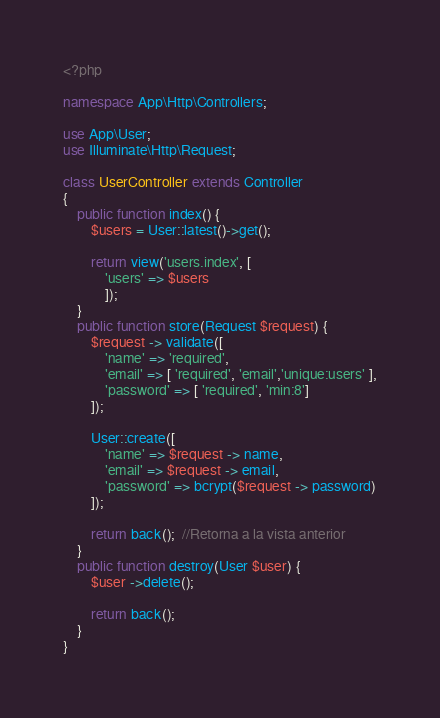Convert code to text. <code><loc_0><loc_0><loc_500><loc_500><_PHP_><?php

namespace App\Http\Controllers;

use App\User;
use Illuminate\Http\Request;

class UserController extends Controller
{
    public function index() {
        $users = User::latest()->get();

        return view('users.index', [
            'users' => $users
            ]);
    }
    public function store(Request $request) {
        $request -> validate([
            'name' => 'required',
            'email' => [ 'required', 'email','unique:users' ],
            'password' => [ 'required', 'min:8']
        ]);

        User::create([
            'name' => $request -> name,
            'email' => $request -> email,
            'password' => bcrypt($request -> password)
        ]);

        return back();  //Retorna a la vista anterior
    }
    public function destroy(User $user) {
        $user ->delete();

        return back();
    }
}
</code> 